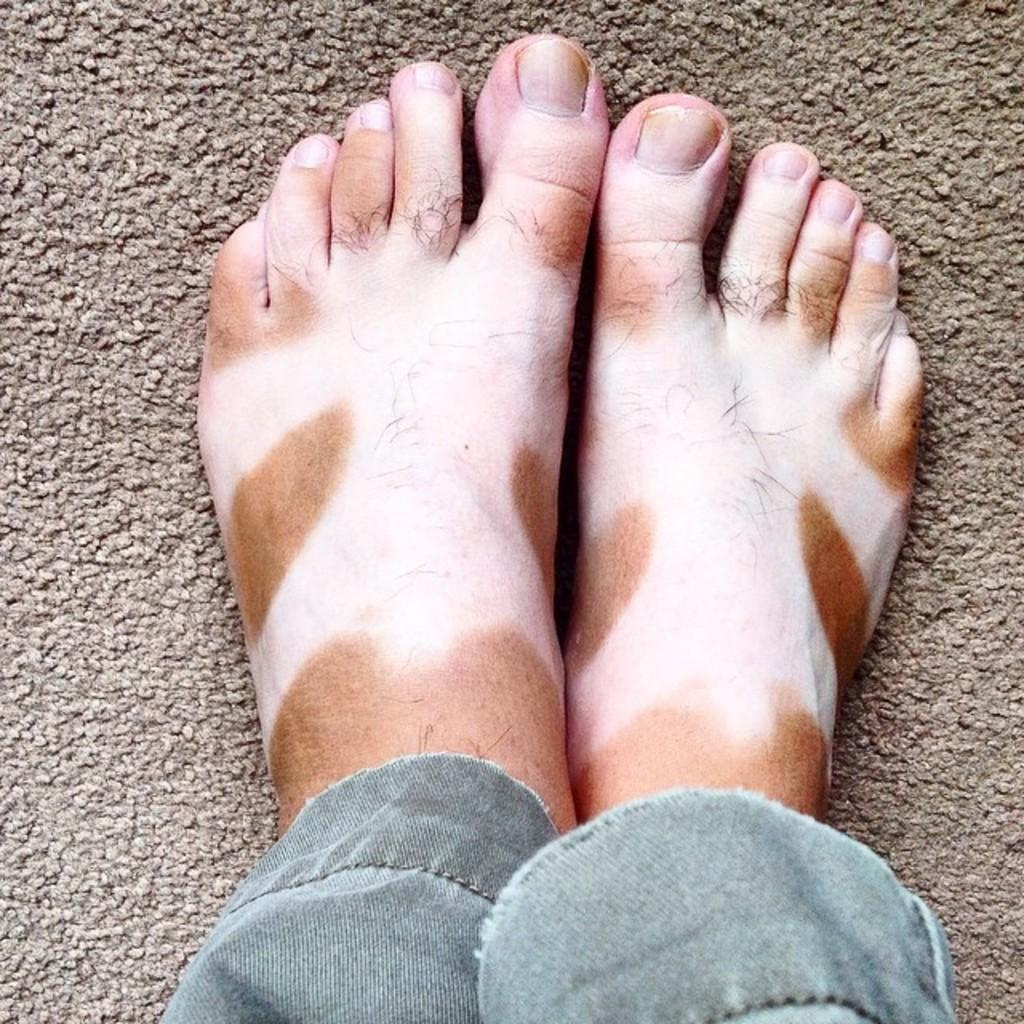What is there is a person in the image, can you describe them? There is a person in the image, and their legs are in two different colors. What is at the bottom of the image? There is a light brown mat at the bottom of the image. Can you see any mist in the image? There is no mention of mist in the provided facts, and therefore it cannot be determined if mist is present in the image. 